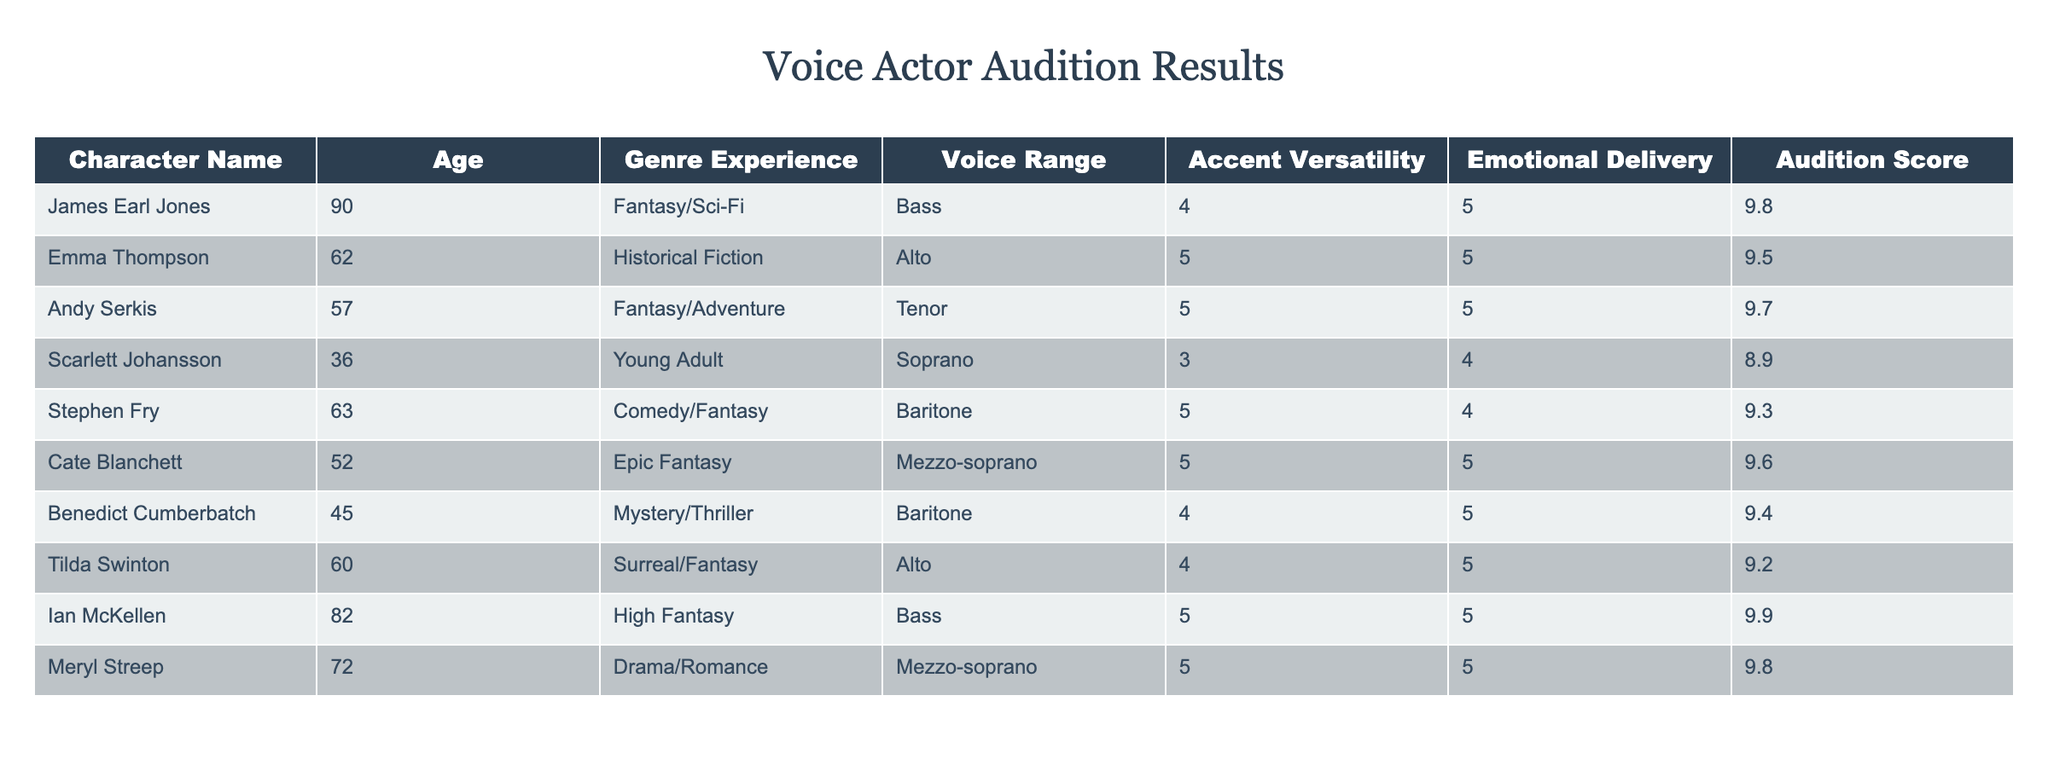What is the highest audition score among the voice actors? The highest audition score in the table is 9.9, which corresponds to Ian McKellen.
Answer: 9.9 Which voice actor has the most versatility in accent? The table indicates that both Ian McKellen and Cate Blanchett have the highest accent versatility rating of 5.
Answer: Ian McKellen, Cate Blanchett What is the average age of the voice actors listed? To find the average age, sum the ages: 90 + 62 + 57 + 36 + 63 + 52 + 45 + 60 + 82 + 72 =  675. There are 10 voice actors, so the average age is 675/10 = 67.5.
Answer: 67.5 Does the table indicate that any voice actor has a score higher than 9.5? Yes, the audition scores of Ian McKellen (9.9) and Meryl Streep (9.8) are both higher than 9.5.
Answer: Yes Which character has the lowest emotional delivery score and what is it? The character with the lowest emotional delivery score is Scarlett Johansson with a score of 4.
Answer: Scarlett Johansson, 4 What is the difference in audition scores between the highest and lowest-rated voice actor? The highest score is 9.9 (Ian McKellen) and the lowest is 8.9 (Scarlett Johansson). The difference is 9.9 - 8.9 = 1.0.
Answer: 1.0 Which genres do the voice actors with the top three audition scores belong to? The top three scores are: Ian McKellen from High Fantasy, Meryl Streep from Drama/Romance, and Andy Serkis from Fantasy/Adventure.
Answer: High Fantasy, Drama/Romance, Fantasy/Adventure How many voice actors have a voice range of Bass? There are three voice actors with a Bass voice range: James Earl Jones, Ian McKellen, and Scarlett Johansson.
Answer: 3 Is there a voice actor in the table who has both a high emotional delivery score and a voice range of Soprano? No, the only Soprano listed is Scarlett Johansson with an emotional delivery score of 4, which is not high.
Answer: No 